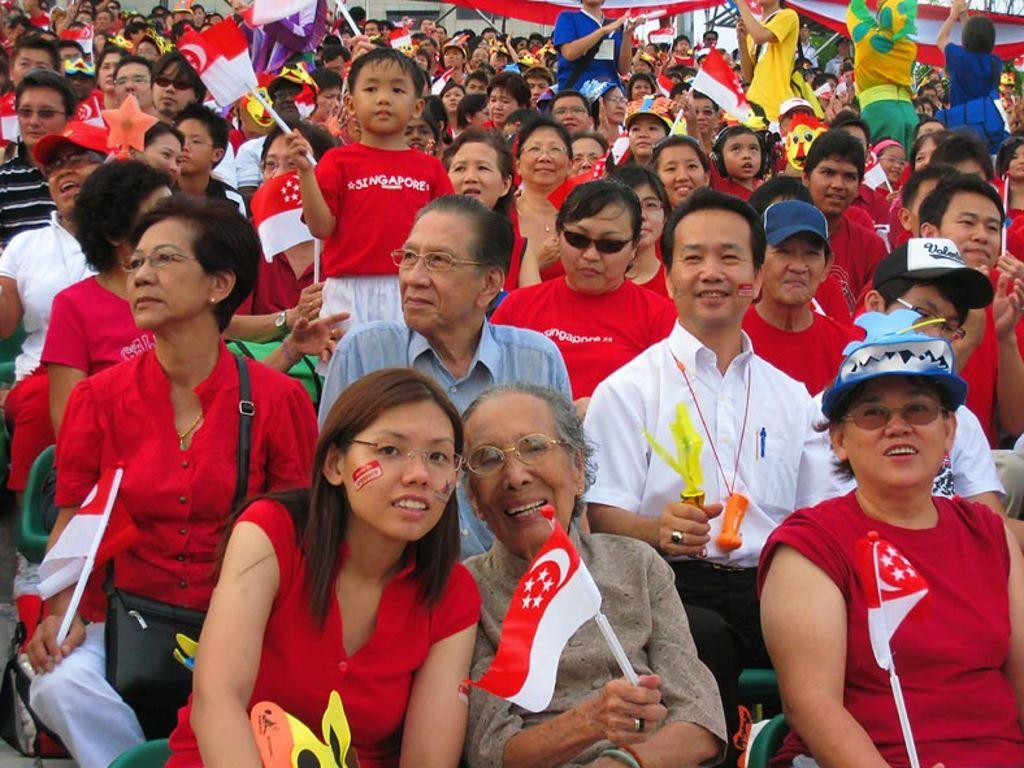How many people are in the image? There is a group of people in the image, but the exact number is not specified. What are some people holding in the image? Some people are holding flags, while others are holding objects. What can be seen in the background of the image? There is a building and a tree visible in the background. What time of day is it in the image, and is there a light bulb visible? The time of day is not specified in the image, and there is no mention of a light bulb. 